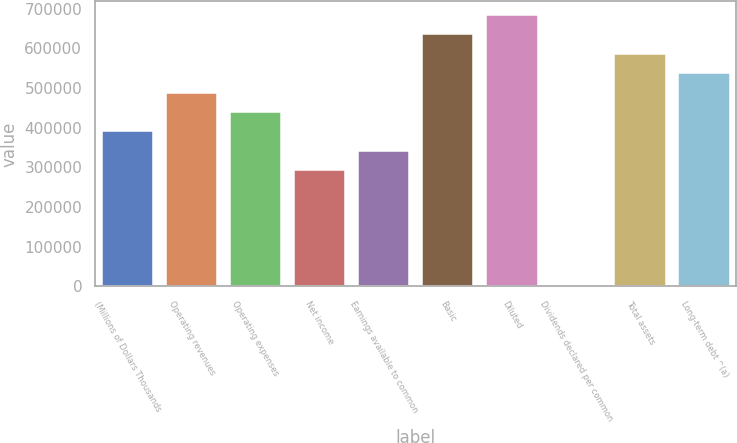Convert chart to OTSL. <chart><loc_0><loc_0><loc_500><loc_500><bar_chart><fcel>(Millions of Dollars Thousands<fcel>Operating revenues<fcel>Operating expenses<fcel>Net income<fcel>Earnings available to common<fcel>Basic<fcel>Diluted<fcel>Dividends declared per common<fcel>Total assets<fcel>Long-term debt ^(a)<nl><fcel>390747<fcel>488434<fcel>439591<fcel>293061<fcel>341904<fcel>634964<fcel>683807<fcel>1.07<fcel>586121<fcel>537277<nl></chart> 